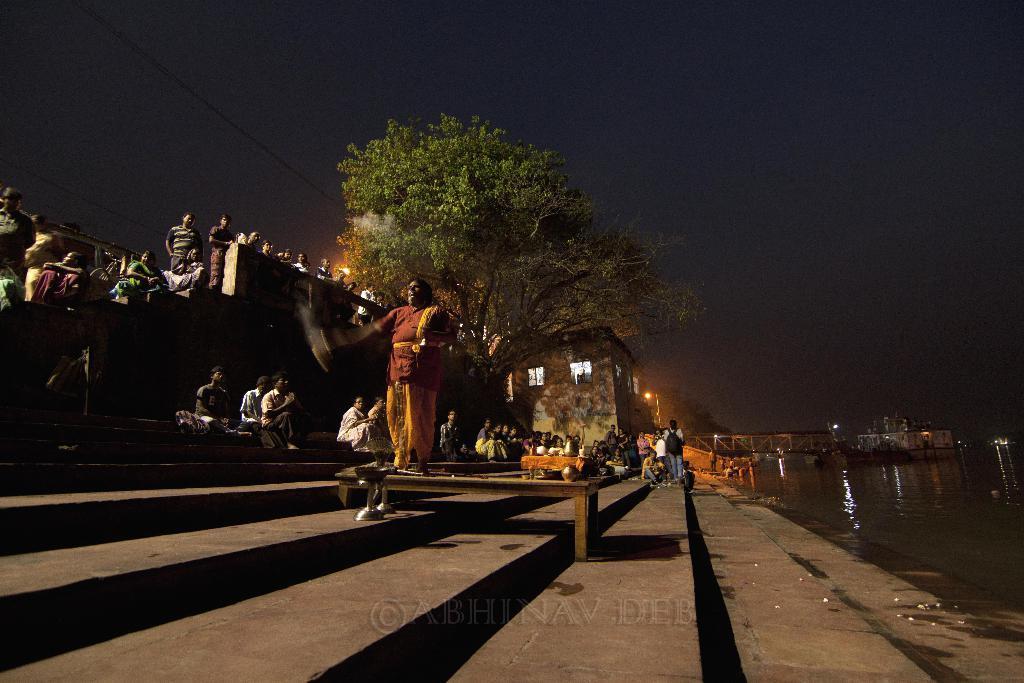Could you give a brief overview of what you see in this image? In the image there are many people sitting on the steps at the river bank and on the right side there is a river. In the background there is a huge tree and some lights. 